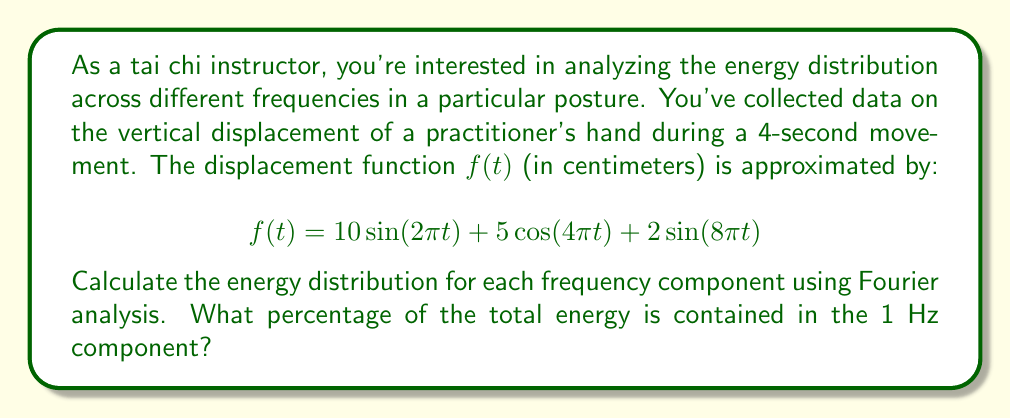Can you solve this math problem? To solve this problem, we'll follow these steps:

1) Identify the frequency components:
   - $\sin(2\pi t)$: 1 Hz
   - $\cos(4\pi t)$: 2 Hz
   - $\sin(8\pi t)$: 4 Hz

2) Calculate the energy of each component:
   The energy of a sinusoidal component $A\sin(2\pi ft)$ or $A\cos(2\pi ft)$ is proportional to $\frac{A^2}{2}$.

   - 1 Hz: $E_1 = \frac{10^2}{2} = 50$
   - 2 Hz: $E_2 = \frac{5^2}{2} = 12.5$
   - 4 Hz: $E_3 = \frac{2^2}{2} = 2$

3) Calculate the total energy:
   $E_{total} = E_1 + E_2 + E_3 = 50 + 12.5 + 2 = 64.5$

4) Calculate the percentage of energy in the 1 Hz component:
   $$\text{Percentage} = \frac{E_1}{E_{total}} \times 100\% = \frac{50}{64.5} \times 100\% \approx 77.52\%$$
Answer: The 1 Hz component contains approximately 77.52% of the total energy. 